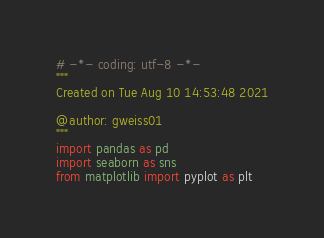<code> <loc_0><loc_0><loc_500><loc_500><_Python_># -*- coding: utf-8 -*-
"""
Created on Tue Aug 10 14:53:48 2021

@author: gweiss01
"""
import pandas as pd
import seaborn as sns
from matplotlib import pyplot as plt</code> 